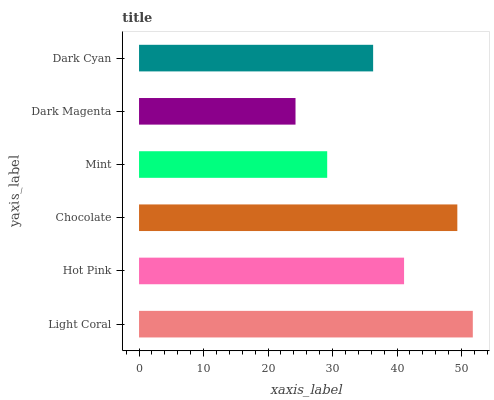Is Dark Magenta the minimum?
Answer yes or no. Yes. Is Light Coral the maximum?
Answer yes or no. Yes. Is Hot Pink the minimum?
Answer yes or no. No. Is Hot Pink the maximum?
Answer yes or no. No. Is Light Coral greater than Hot Pink?
Answer yes or no. Yes. Is Hot Pink less than Light Coral?
Answer yes or no. Yes. Is Hot Pink greater than Light Coral?
Answer yes or no. No. Is Light Coral less than Hot Pink?
Answer yes or no. No. Is Hot Pink the high median?
Answer yes or no. Yes. Is Dark Cyan the low median?
Answer yes or no. Yes. Is Dark Magenta the high median?
Answer yes or no. No. Is Light Coral the low median?
Answer yes or no. No. 